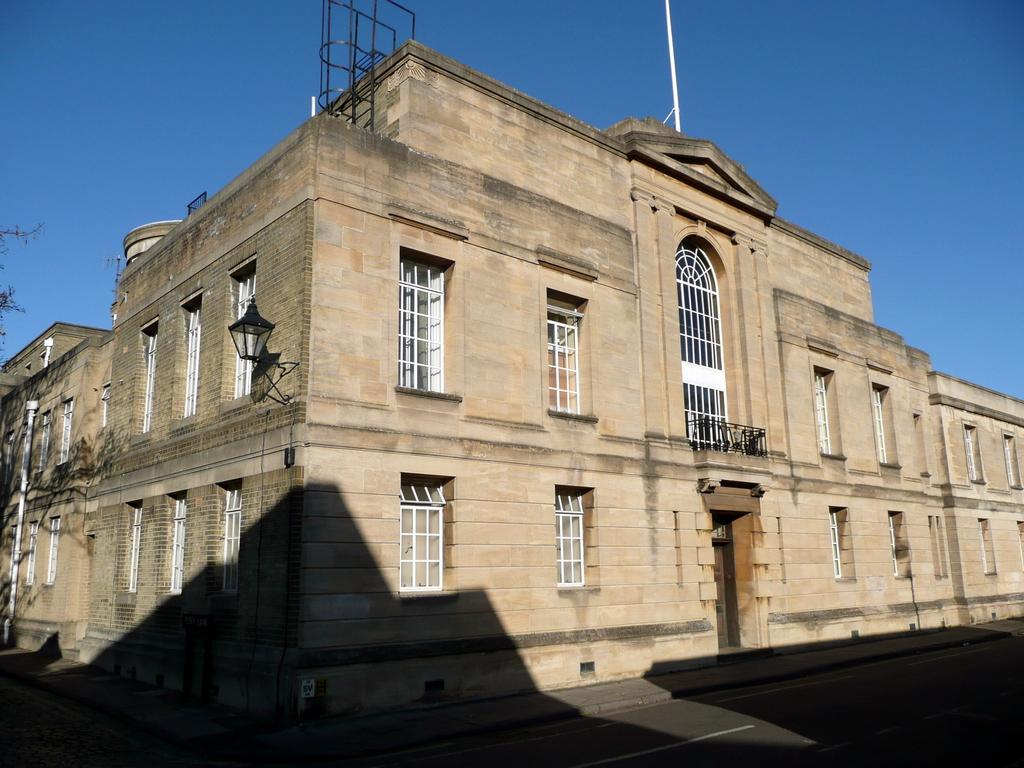What type of structure is present in the image? There is a building in the image. What feature can be seen on the building? The building has windows and an arch. What additional object is present in the image? There is a lantern in the image. What can be found on the left side of the image? There is a plant on the left side of the image. What is the color of the sky in the image? The sky is blue in color. What theory is being proposed in the image? There is no theory being proposed in the image; it is a visual representation of a building, lantern, plant, and sky. 